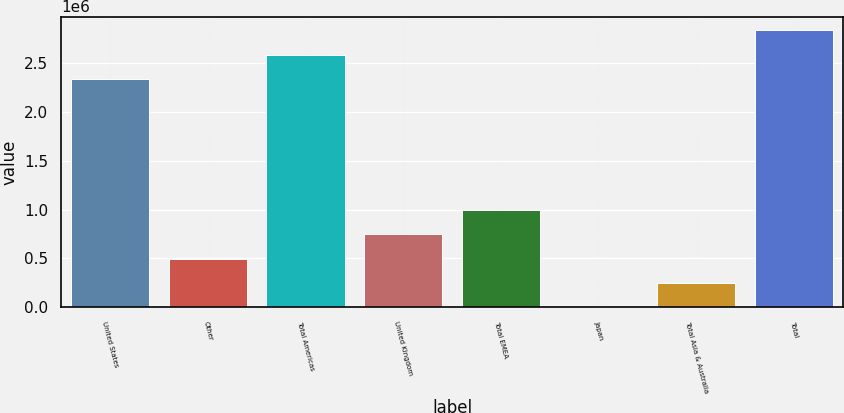Convert chart to OTSL. <chart><loc_0><loc_0><loc_500><loc_500><bar_chart><fcel>United States<fcel>Other<fcel>Total Americas<fcel>United Kingdom<fcel>Total EMEA<fcel>Japan<fcel>Total Asia & Australia<fcel>Total<nl><fcel>2.33488e+06<fcel>498618<fcel>2.58404e+06<fcel>747779<fcel>996939<fcel>297<fcel>249458<fcel>2.8332e+06<nl></chart> 